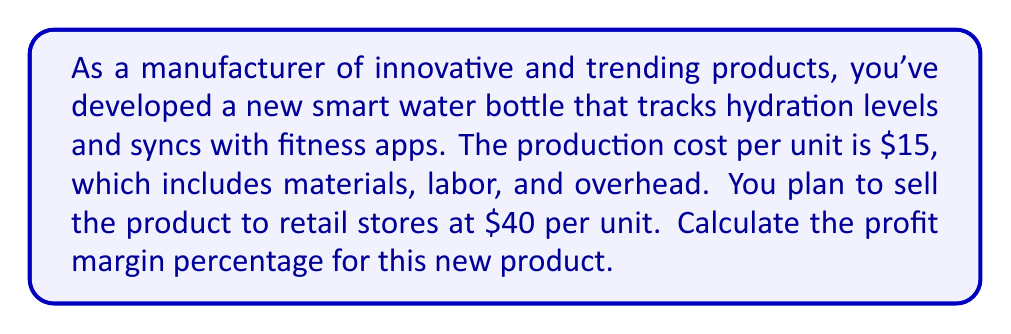What is the answer to this math problem? To calculate the profit margin percentage, we need to follow these steps:

1. Calculate the profit per unit:
   Profit per unit = Selling price - Production cost
   $$ \text{Profit per unit} = $40 - $15 = $25 $$

2. Calculate the profit margin:
   Profit margin = Profit per unit ÷ Selling price
   $$ \text{Profit margin} = \frac{$25}{$40} = 0.625 $$

3. Convert the profit margin to a percentage:
   Profit margin percentage = Profit margin × 100%
   $$ \text{Profit margin percentage} = 0.625 \times 100\% = 62.5\% $$

The profit margin percentage represents the portion of the selling price that is profit. In this case, 62.5% of the selling price is profit.
Answer: The profit margin percentage for the new smart water bottle is 62.5%. 